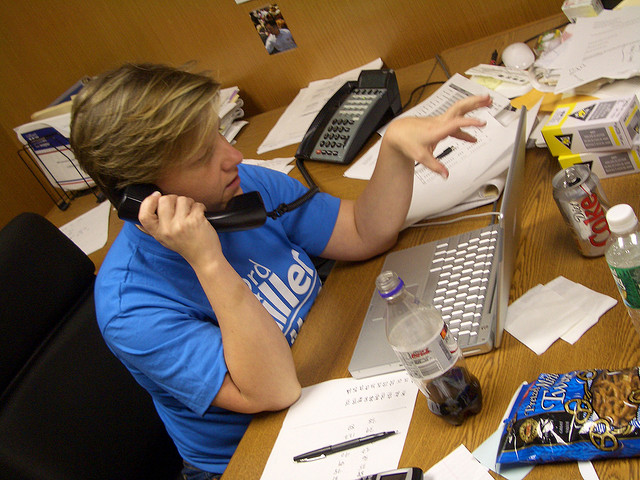Identify and read out the text in this image. Coke Diet 